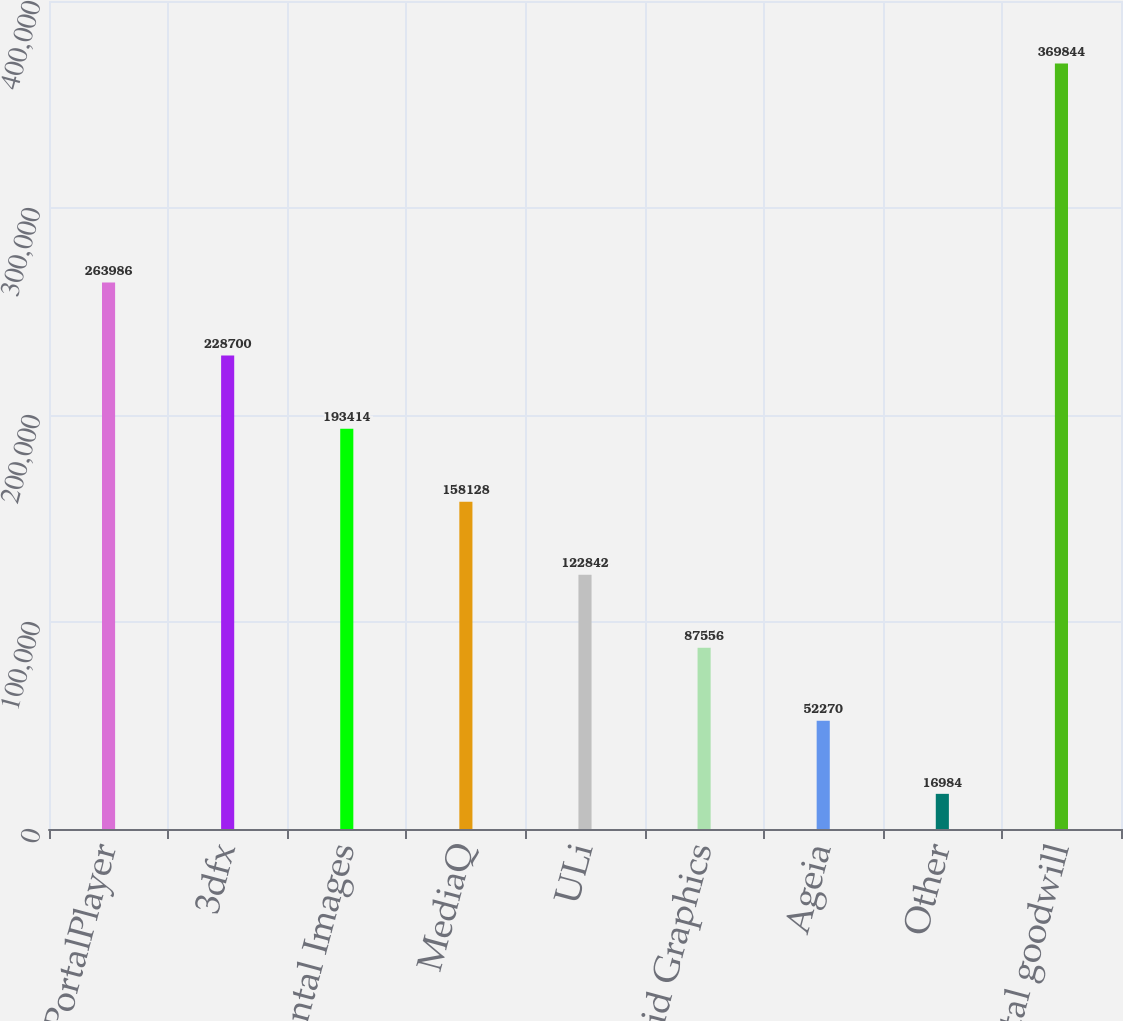Convert chart to OTSL. <chart><loc_0><loc_0><loc_500><loc_500><bar_chart><fcel>PortalPlayer<fcel>3dfx<fcel>Mental Images<fcel>MediaQ<fcel>ULi<fcel>Hybrid Graphics<fcel>Ageia<fcel>Other<fcel>Total goodwill<nl><fcel>263986<fcel>228700<fcel>193414<fcel>158128<fcel>122842<fcel>87556<fcel>52270<fcel>16984<fcel>369844<nl></chart> 